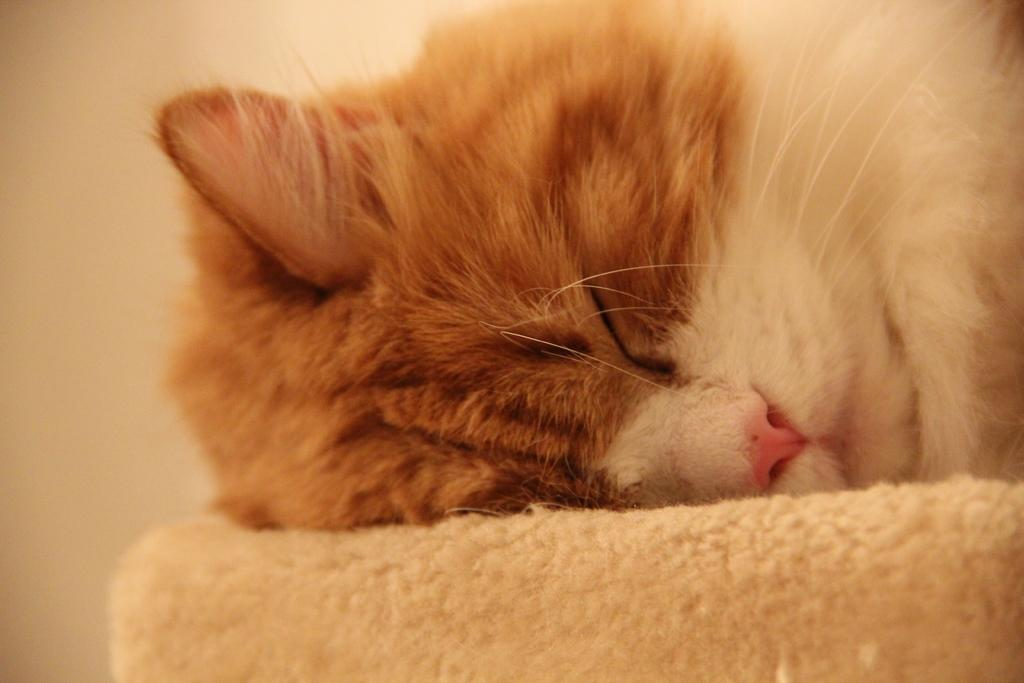What type of animal is in the image? There is a cat in the image. Can you describe the color of the cat? The cat is white and light brown in color. What is visible in the background of the image? There is a wall in the image. What type of fruit can be seen hanging from the wall in the image? There is no fruit hanging from the wall in the image. Can you tell me how many tigers are visible in the image? There are no tigers present in the image. 